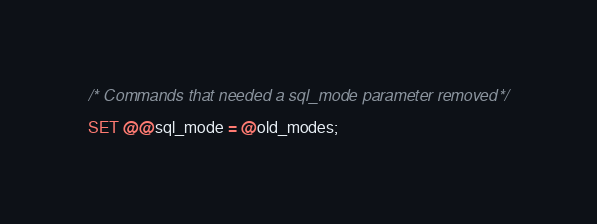Convert code to text. <code><loc_0><loc_0><loc_500><loc_500><_SQL_>
/* Commands that needed a sql_mode parameter removed */

SET @@sql_mode = @old_modes;</code> 